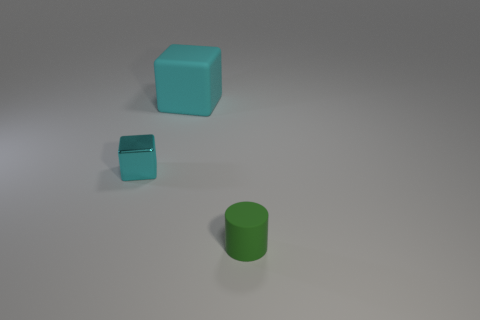What is the thing left of the matte thing that is behind the green cylinder made of?
Ensure brevity in your answer.  Metal. What color is the block that is the same size as the matte cylinder?
Provide a short and direct response. Cyan. There is a green object; is its shape the same as the thing behind the small cyan cube?
Provide a short and direct response. No. What shape is the big matte thing that is the same color as the tiny cube?
Provide a succinct answer. Cube. There is a matte object to the left of the thing that is to the right of the big matte block; how many green things are on the left side of it?
Offer a very short reply. 0. There is a thing on the right side of the rubber thing behind the tiny green matte object; how big is it?
Make the answer very short. Small. The cylinder that is made of the same material as the big cyan cube is what size?
Your answer should be compact. Small. There is a object that is both behind the green rubber cylinder and in front of the large cyan rubber object; what is its shape?
Offer a terse response. Cube. Are there the same number of blocks to the right of the tiny green thing and metallic cubes?
Provide a succinct answer. No. How many objects are either green cylinders or cyan things that are to the right of the small cyan block?
Give a very brief answer. 2. 